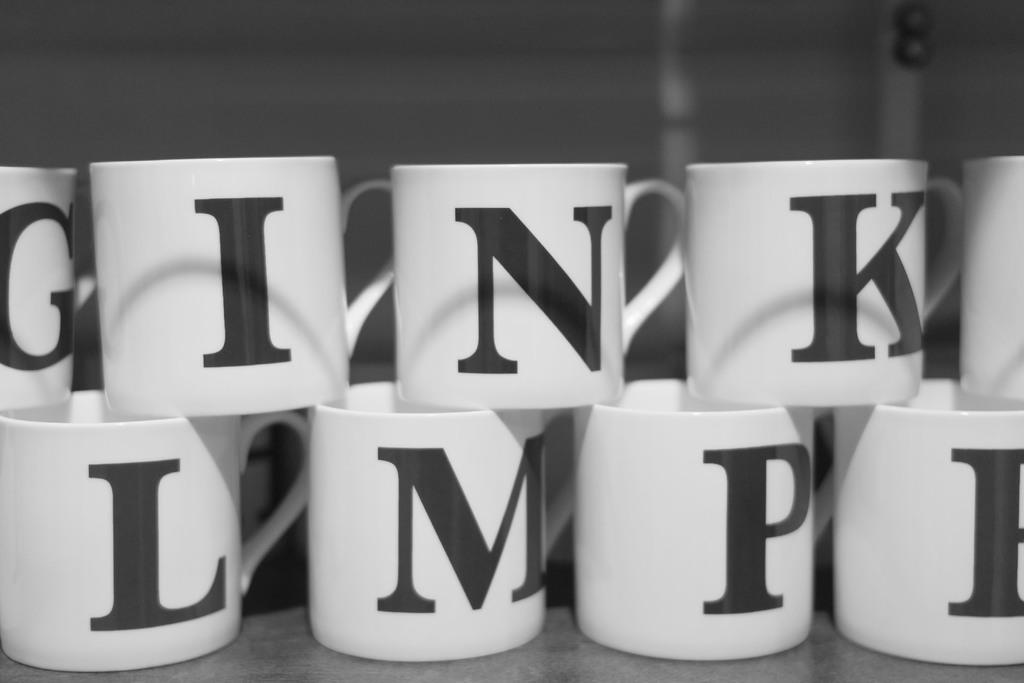What letter is on the mug at the bottom left?
Provide a succinct answer. L. What letter does the mug on the bottom left have on it?
Keep it short and to the point. L. 